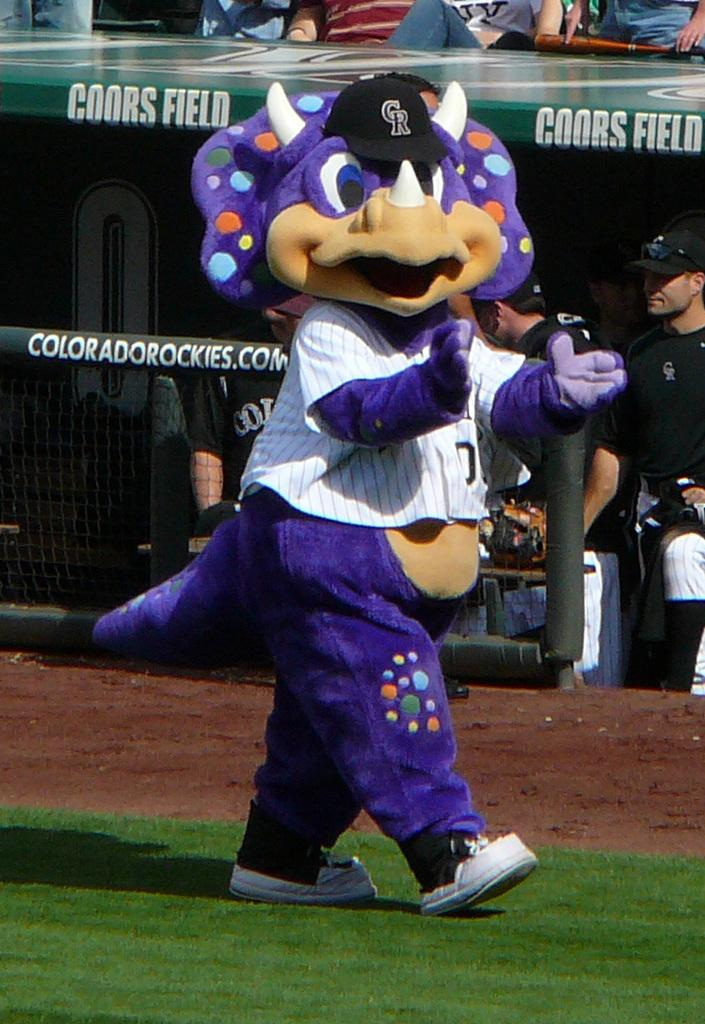<image>
Offer a succinct explanation of the picture presented. A Coloroda Rockies dinosaur mascot walking on  the grass at Coors field. 